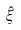<formula> <loc_0><loc_0><loc_500><loc_500>\hat { \xi }</formula> 